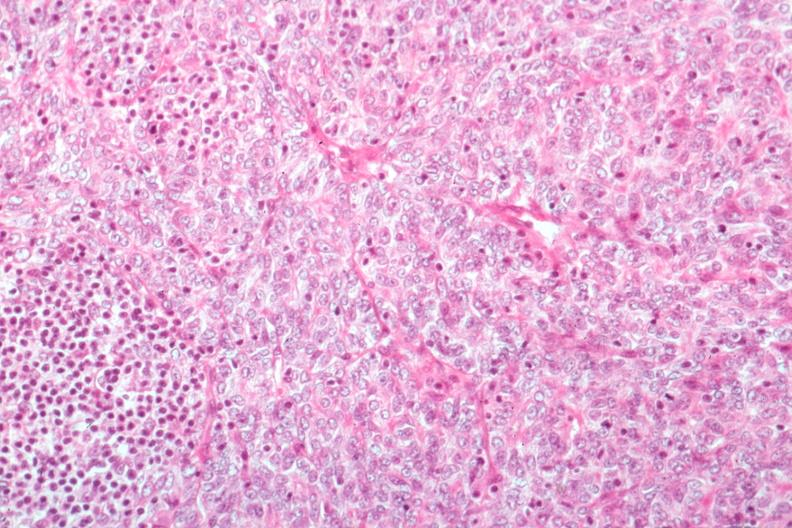s subcapsular hematoma present?
Answer the question using a single word or phrase. No 